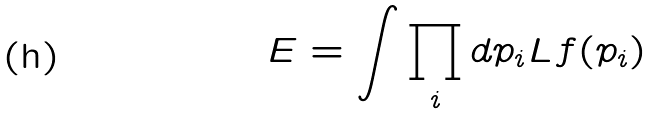Convert formula to latex. <formula><loc_0><loc_0><loc_500><loc_500>E = \int \prod _ { i } d p _ { i } L f ( p _ { i } )</formula> 